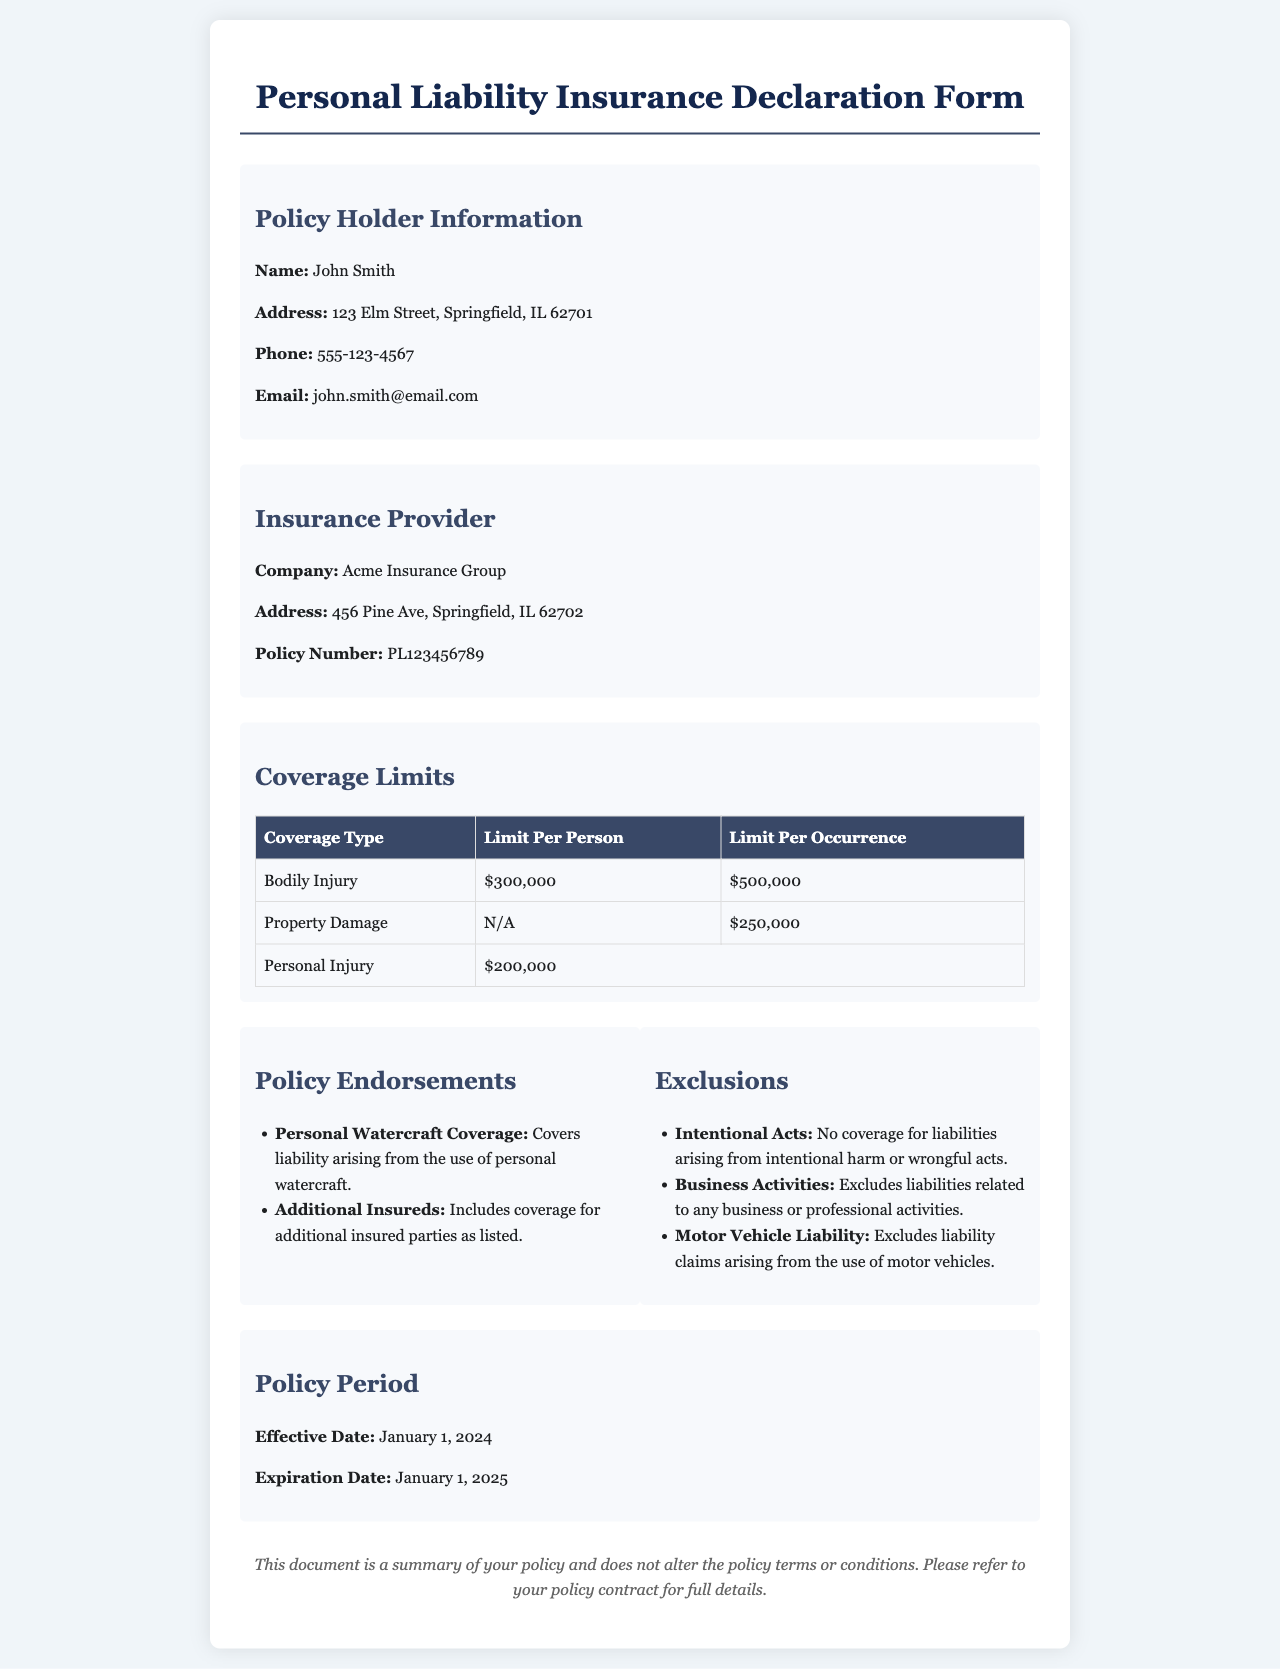What is the name of the policy holder? The name of the policy holder is stated clearly in the document under Policy Holder Information.
Answer: John Smith What is the policy number? The policy number can be found in the Insurance Provider section of the document.
Answer: PL123456789 What is the limit for bodily injury per occurrence? The limit for bodily injury per occurrence is detailed in the Coverage Limits table.
Answer: $500,000 Which company provides this insurance policy? The insurance provider's company name is provided under the Insurance Provider section.
Answer: Acme Insurance Group What is the effective date of the policy? The effective date can be located in the Policy Period section of the document.
Answer: January 1, 2024 What type of coverage is included as an endorsement? An endorsement is a specific type of coverage that is highlighted in the Policy Endorsements section.
Answer: Personal Watercraft Coverage Are business activities covered under this policy? The policy explicitly mentions this under the Exclusions section which outlines what is not covered.
Answer: No How many limits are provided for Personal Injury coverage? The Coverage Limits table specifies the limit for personal injury coverage.
Answer: $200,000 What is the expiration date of the insurance policy? The expiration date is mentioned in the Policy Period section of the document.
Answer: January 1, 2025 